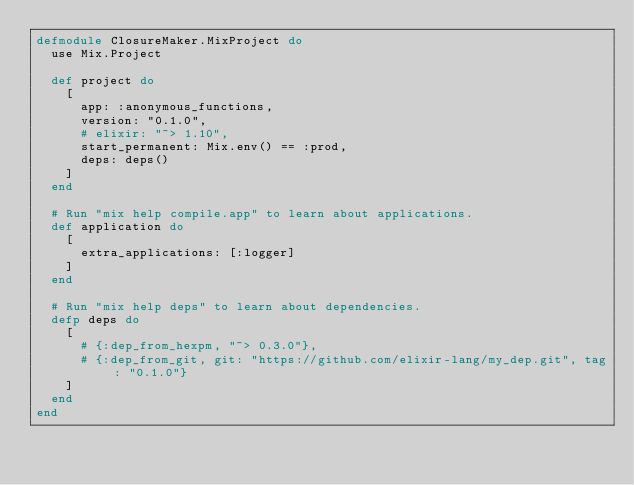Convert code to text. <code><loc_0><loc_0><loc_500><loc_500><_Elixir_>defmodule ClosureMaker.MixProject do
  use Mix.Project

  def project do
    [
      app: :anonymous_functions,
      version: "0.1.0",
      # elixir: "~> 1.10",
      start_permanent: Mix.env() == :prod,
      deps: deps()
    ]
  end

  # Run "mix help compile.app" to learn about applications.
  def application do
    [
      extra_applications: [:logger]
    ]
  end

  # Run "mix help deps" to learn about dependencies.
  defp deps do
    [
      # {:dep_from_hexpm, "~> 0.3.0"},
      # {:dep_from_git, git: "https://github.com/elixir-lang/my_dep.git", tag: "0.1.0"}
    ]
  end
end
</code> 